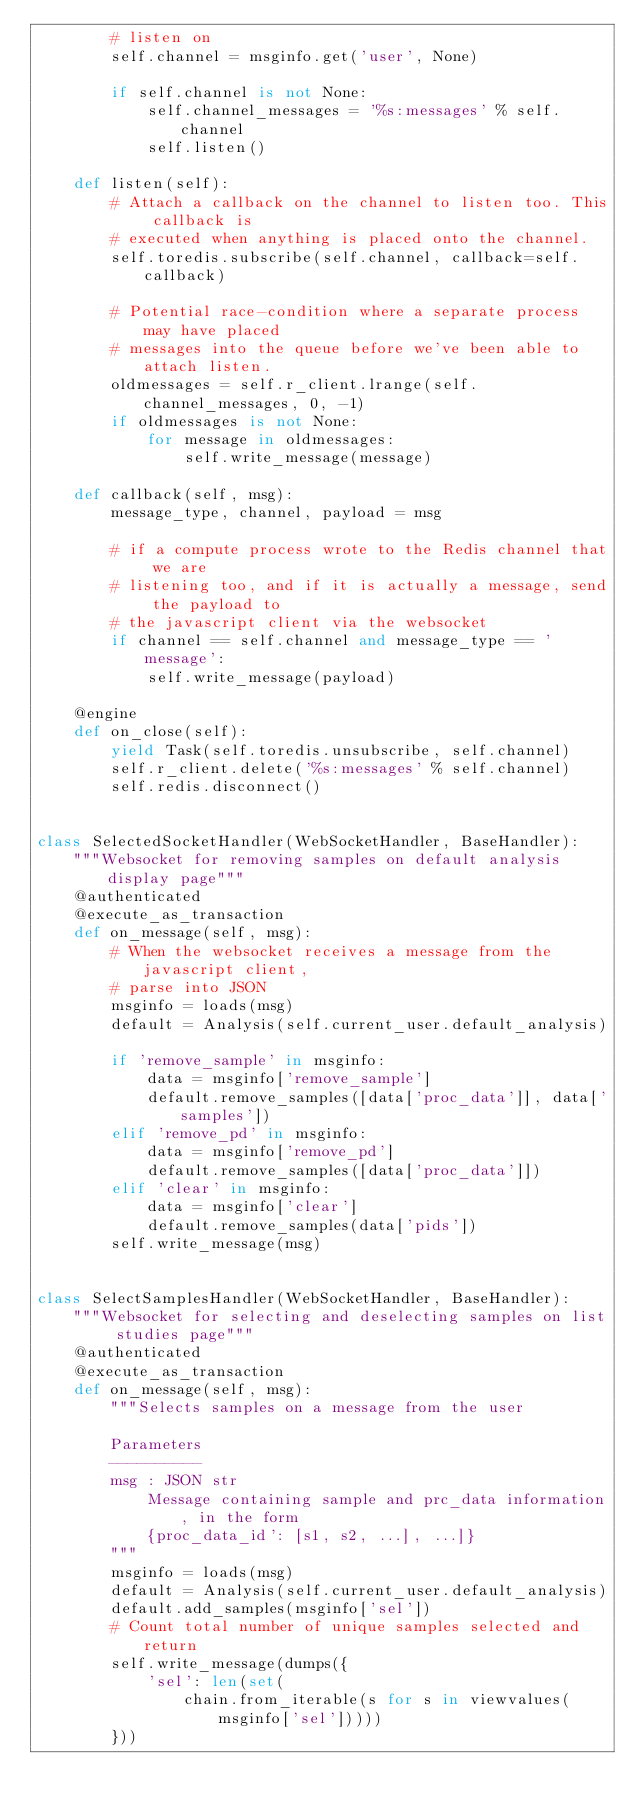<code> <loc_0><loc_0><loc_500><loc_500><_Python_>        # listen on
        self.channel = msginfo.get('user', None)

        if self.channel is not None:
            self.channel_messages = '%s:messages' % self.channel
            self.listen()

    def listen(self):
        # Attach a callback on the channel to listen too. This callback is
        # executed when anything is placed onto the channel.
        self.toredis.subscribe(self.channel, callback=self.callback)

        # Potential race-condition where a separate process may have placed
        # messages into the queue before we've been able to attach listen.
        oldmessages = self.r_client.lrange(self.channel_messages, 0, -1)
        if oldmessages is not None:
            for message in oldmessages:
                self.write_message(message)

    def callback(self, msg):
        message_type, channel, payload = msg

        # if a compute process wrote to the Redis channel that we are
        # listening too, and if it is actually a message, send the payload to
        # the javascript client via the websocket
        if channel == self.channel and message_type == 'message':
            self.write_message(payload)

    @engine
    def on_close(self):
        yield Task(self.toredis.unsubscribe, self.channel)
        self.r_client.delete('%s:messages' % self.channel)
        self.redis.disconnect()


class SelectedSocketHandler(WebSocketHandler, BaseHandler):
    """Websocket for removing samples on default analysis display page"""
    @authenticated
    @execute_as_transaction
    def on_message(self, msg):
        # When the websocket receives a message from the javascript client,
        # parse into JSON
        msginfo = loads(msg)
        default = Analysis(self.current_user.default_analysis)

        if 'remove_sample' in msginfo:
            data = msginfo['remove_sample']
            default.remove_samples([data['proc_data']], data['samples'])
        elif 'remove_pd' in msginfo:
            data = msginfo['remove_pd']
            default.remove_samples([data['proc_data']])
        elif 'clear' in msginfo:
            data = msginfo['clear']
            default.remove_samples(data['pids'])
        self.write_message(msg)


class SelectSamplesHandler(WebSocketHandler, BaseHandler):
    """Websocket for selecting and deselecting samples on list studies page"""
    @authenticated
    @execute_as_transaction
    def on_message(self, msg):
        """Selects samples on a message from the user

        Parameters
        ----------
        msg : JSON str
            Message containing sample and prc_data information, in the form
            {proc_data_id': [s1, s2, ...], ...]}
        """
        msginfo = loads(msg)
        default = Analysis(self.current_user.default_analysis)
        default.add_samples(msginfo['sel'])
        # Count total number of unique samples selected and return
        self.write_message(dumps({
            'sel': len(set(
                chain.from_iterable(s for s in viewvalues(msginfo['sel']))))
        }))
</code> 